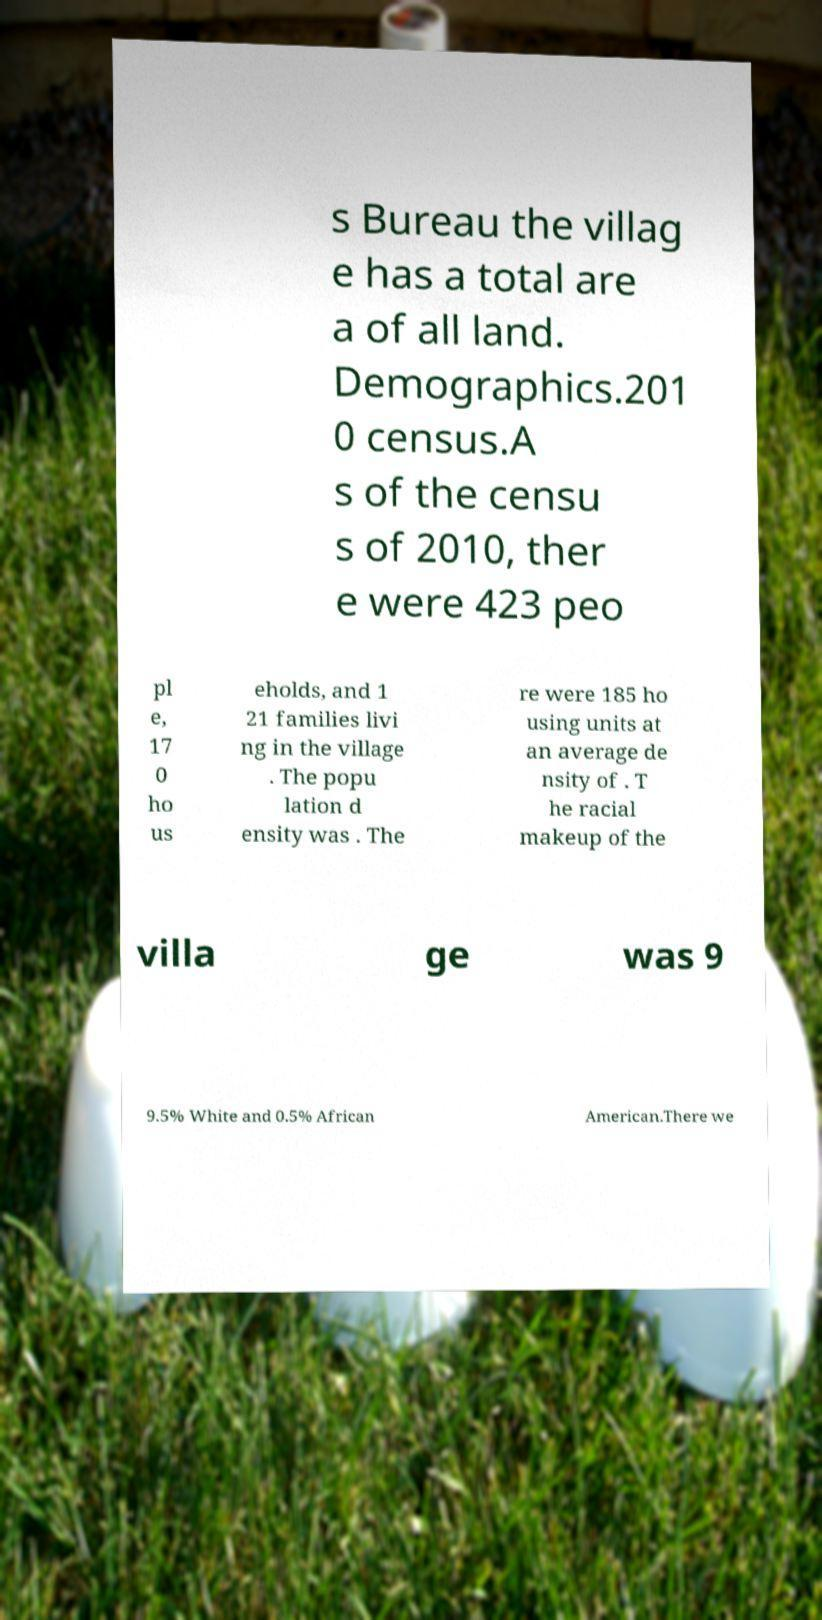Please read and relay the text visible in this image. What does it say? s Bureau the villag e has a total are a of all land. Demographics.201 0 census.A s of the censu s of 2010, ther e were 423 peo pl e, 17 0 ho us eholds, and 1 21 families livi ng in the village . The popu lation d ensity was . The re were 185 ho using units at an average de nsity of . T he racial makeup of the villa ge was 9 9.5% White and 0.5% African American.There we 